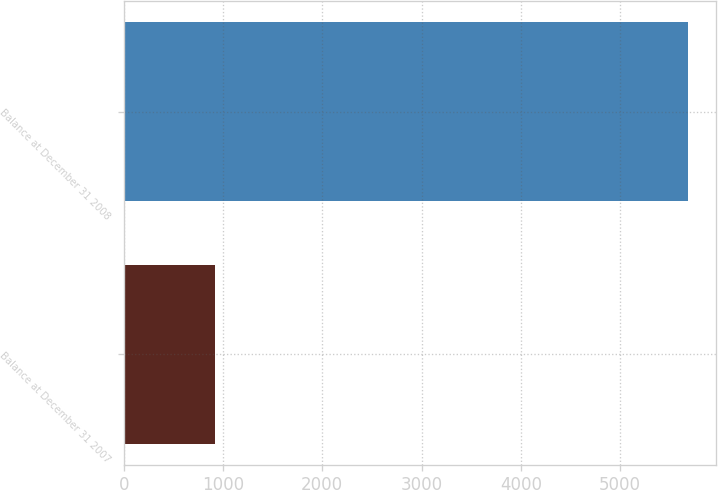Convert chart to OTSL. <chart><loc_0><loc_0><loc_500><loc_500><bar_chart><fcel>Balance at December 31 2007<fcel>Balance at December 31 2008<nl><fcel>917<fcel>5687<nl></chart> 